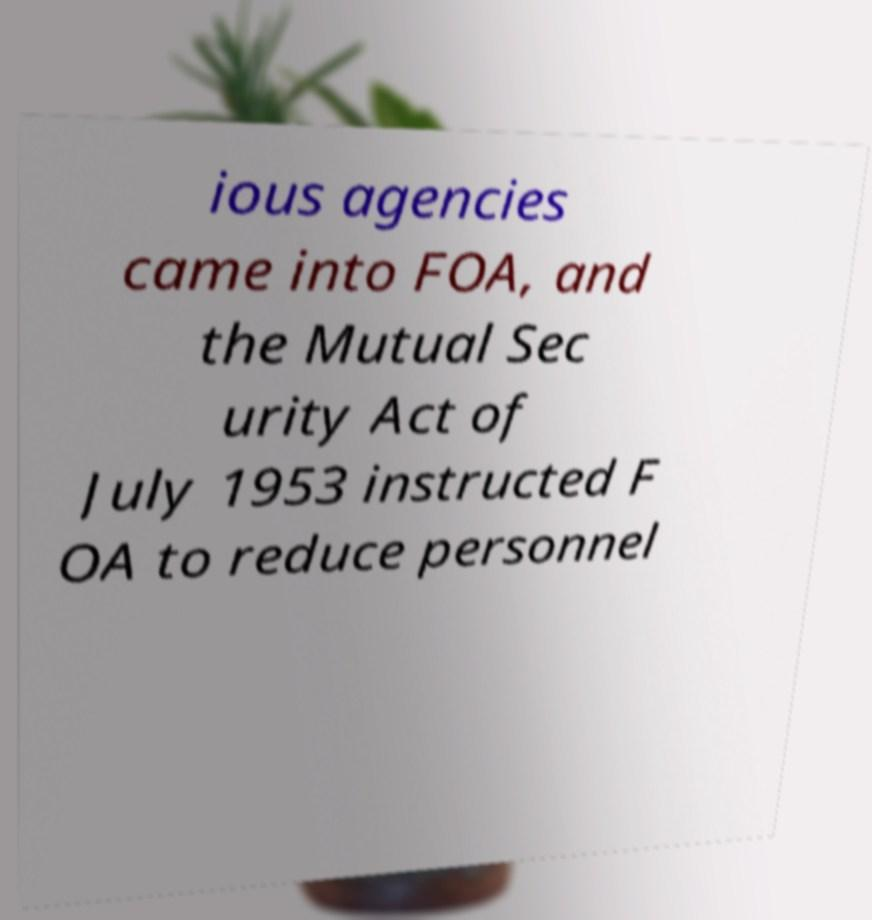Can you accurately transcribe the text from the provided image for me? ious agencies came into FOA, and the Mutual Sec urity Act of July 1953 instructed F OA to reduce personnel 